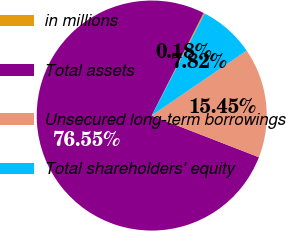<chart> <loc_0><loc_0><loc_500><loc_500><pie_chart><fcel>in millions<fcel>Total assets<fcel>Unsecured long-term borrowings<fcel>Total shareholders' equity<nl><fcel>0.18%<fcel>76.55%<fcel>15.45%<fcel>7.82%<nl></chart> 